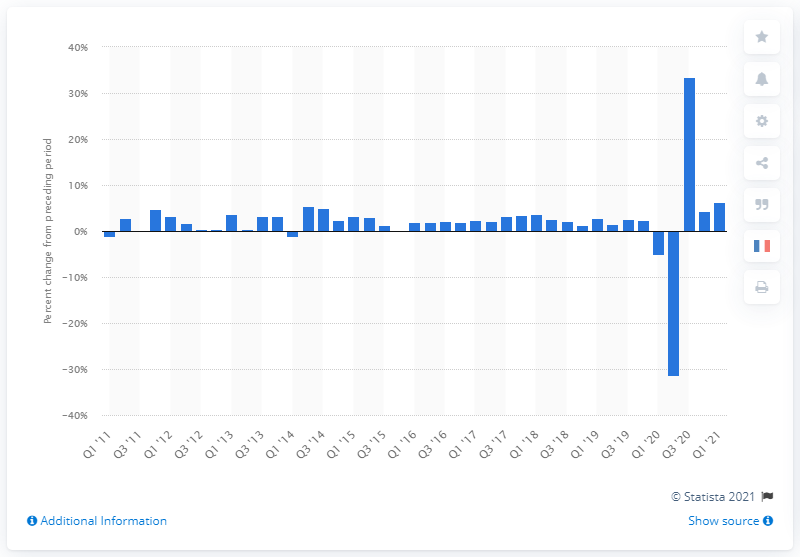Indicate a few pertinent items in this graphic. The real U.S. Gross Domestic Product (GDP) increased by 6.4% in the first quarter of 2021. In the fourth quarter of 2019, the Gross Domestic Product (GDP) increased by 2.4%. 